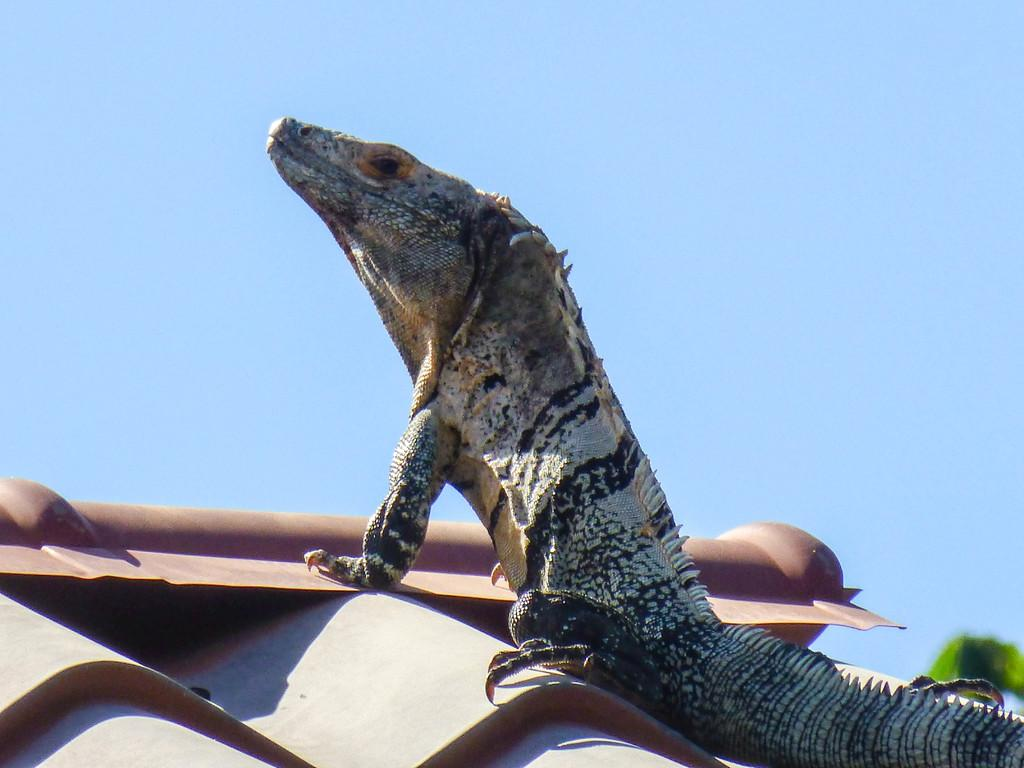What type of animal is in the image? There is a lizard in the image. Where is the lizard located? The lizard is on a rooftop. What can be seen in the background of the image? The sky is visible in the background of the image. How many geese are flying in the zephyr in the image? There are no geese or zephyr present in the image; it features a lizard on a rooftop with a visible sky in the background. 